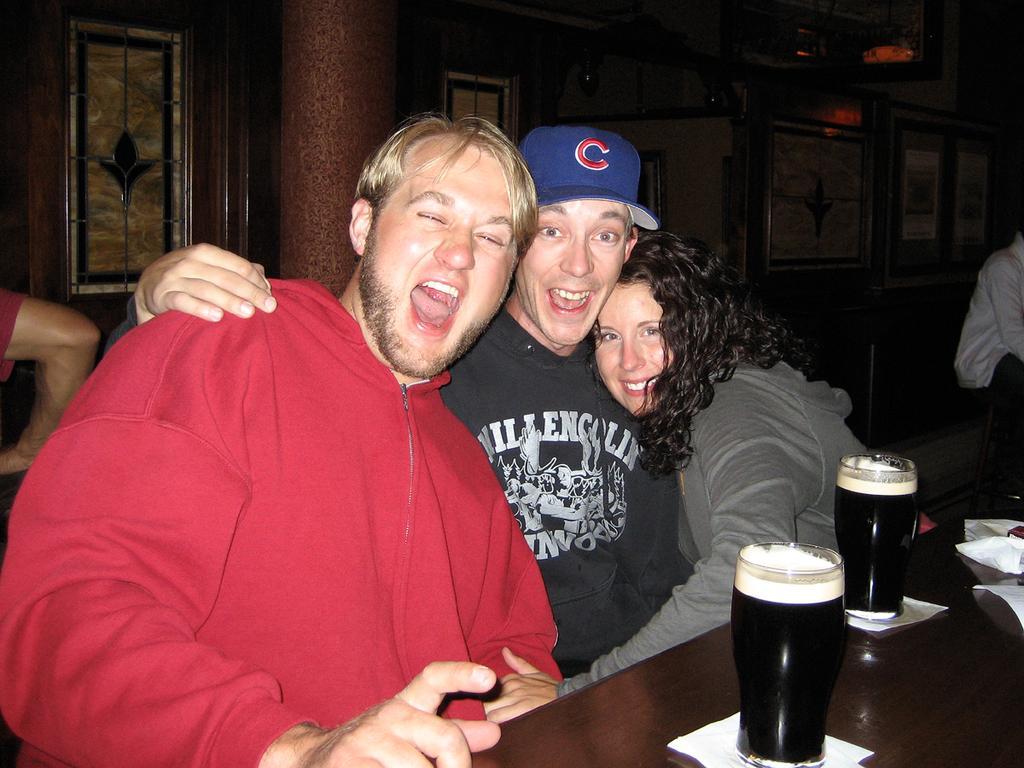How would you summarize this image in a sentence or two? In the center of the image we can see three people sitting and smiling, before them there is a table and we can see glasses filled with drink and napkins placed on the table. In the background there are people, pillar and a wall. 